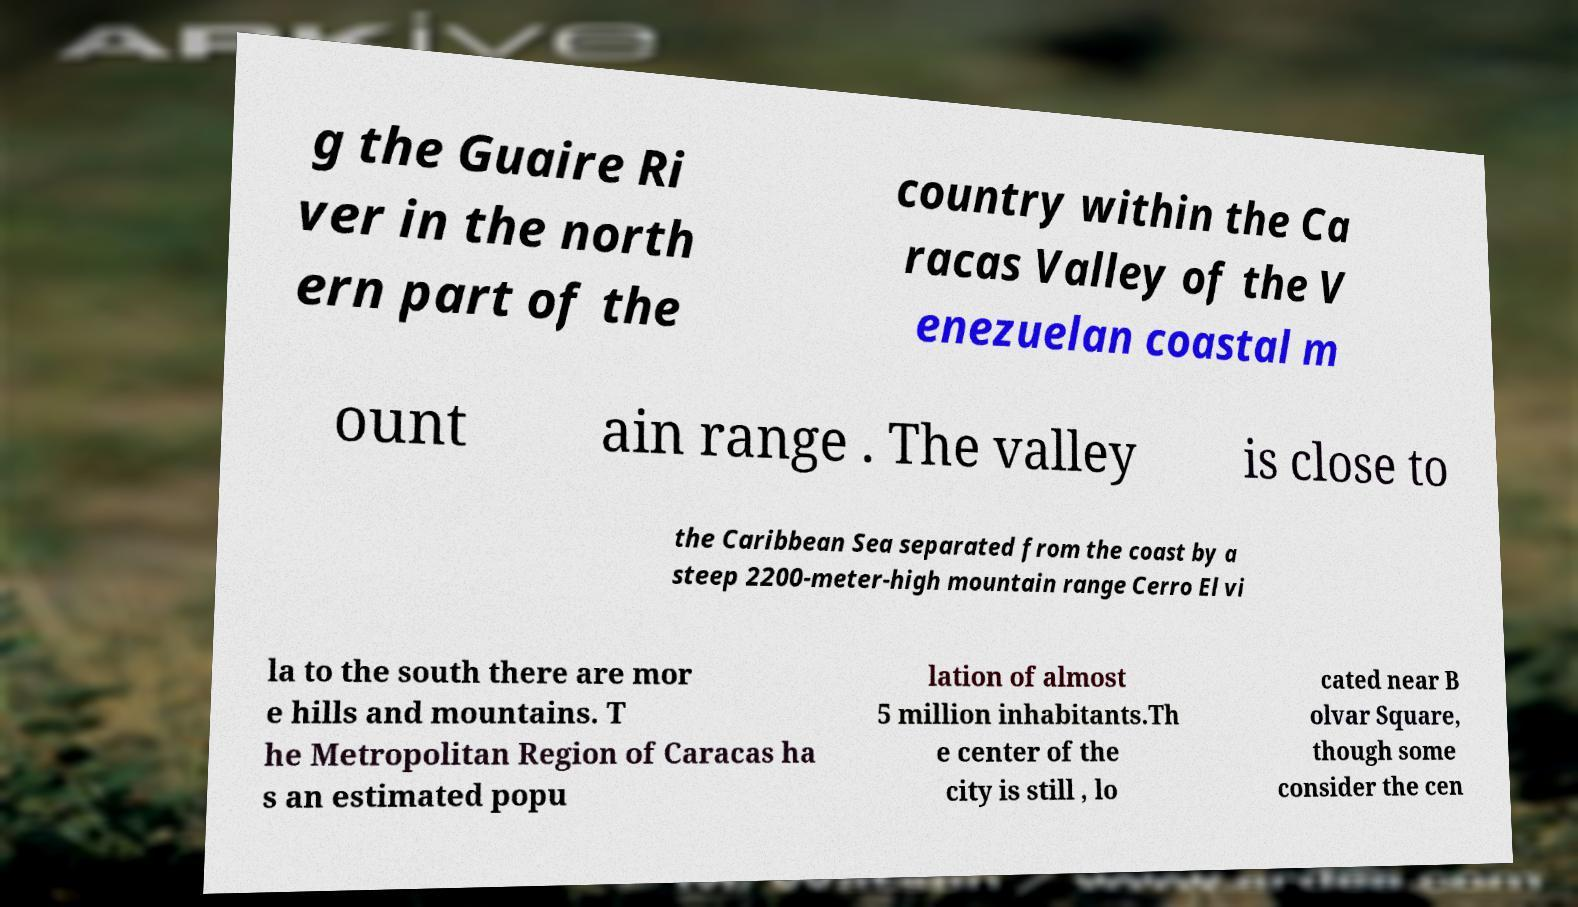Could you assist in decoding the text presented in this image and type it out clearly? g the Guaire Ri ver in the north ern part of the country within the Ca racas Valley of the V enezuelan coastal m ount ain range . The valley is close to the Caribbean Sea separated from the coast by a steep 2200-meter-high mountain range Cerro El vi la to the south there are mor e hills and mountains. T he Metropolitan Region of Caracas ha s an estimated popu lation of almost 5 million inhabitants.Th e center of the city is still , lo cated near B olvar Square, though some consider the cen 